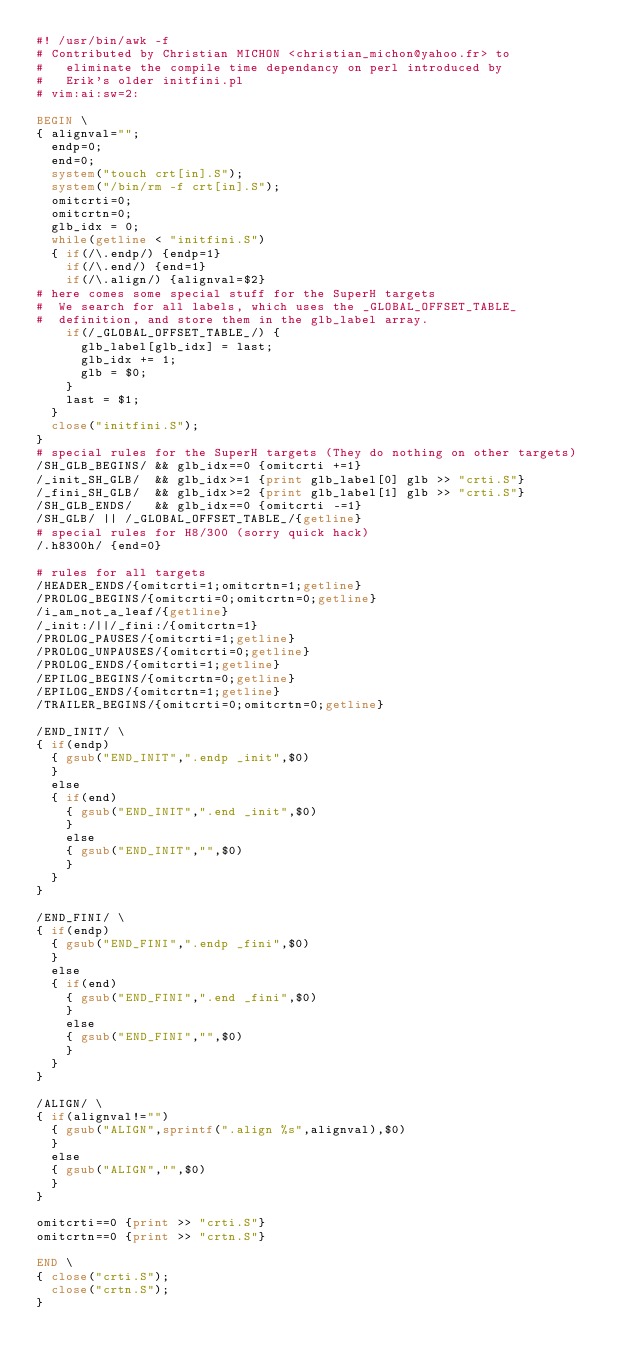Convert code to text. <code><loc_0><loc_0><loc_500><loc_500><_Awk_>#! /usr/bin/awk -f
# Contributed by Christian MICHON <christian_michon@yahoo.fr> to
#   eliminate the compile time dependancy on perl introduced by 
#   Erik's older initfini.pl 
# vim:ai:sw=2:

BEGIN \
{ alignval="";
  endp=0;
  end=0;
  system("touch crt[in].S");
  system("/bin/rm -f crt[in].S");
  omitcrti=0;
  omitcrtn=0;
  glb_idx = 0;
  while(getline < "initfini.S")
  { if(/\.endp/) {endp=1}
    if(/\.end/) {end=1}
    if(/\.align/) {alignval=$2}
# here comes some special stuff for the SuperH targets
#  We search for all labels, which uses the _GLOBAL_OFFSET_TABLE_
#  definition, and store them in the glb_label array.
    if(/_GLOBAL_OFFSET_TABLE_/) {
      glb_label[glb_idx] = last;
      glb_idx += 1;
      glb = $0;
    }
    last = $1;
  }
  close("initfini.S");
}
# special rules for the SuperH targets (They do nothing on other targets)
/SH_GLB_BEGINS/ && glb_idx==0 {omitcrti +=1}
/_init_SH_GLB/  && glb_idx>=1 {print glb_label[0] glb >> "crti.S"}
/_fini_SH_GLB/  && glb_idx>=2 {print glb_label[1] glb >> "crti.S"}
/SH_GLB_ENDS/   && glb_idx==0 {omitcrti -=1}
/SH_GLB/ || /_GLOBAL_OFFSET_TABLE_/{getline}
# special rules for H8/300 (sorry quick hack)
/.h8300h/ {end=0}

# rules for all targets
/HEADER_ENDS/{omitcrti=1;omitcrtn=1;getline}
/PROLOG_BEGINS/{omitcrti=0;omitcrtn=0;getline}
/i_am_not_a_leaf/{getline}
/_init:/||/_fini:/{omitcrtn=1}
/PROLOG_PAUSES/{omitcrti=1;getline}
/PROLOG_UNPAUSES/{omitcrti=0;getline}
/PROLOG_ENDS/{omitcrti=1;getline}
/EPILOG_BEGINS/{omitcrtn=0;getline}
/EPILOG_ENDS/{omitcrtn=1;getline}
/TRAILER_BEGINS/{omitcrti=0;omitcrtn=0;getline}

/END_INIT/ \
{ if(endp)
  { gsub("END_INIT",".endp _init",$0)
  }
  else
  { if(end)
    { gsub("END_INIT",".end _init",$0)
    }
    else
    { gsub("END_INIT","",$0)
    }
  }
}

/END_FINI/ \
{ if(endp)
  { gsub("END_FINI",".endp _fini",$0)
  }
  else
  { if(end)
    { gsub("END_FINI",".end _fini",$0)
    }
    else
    { gsub("END_FINI","",$0)
    }
  }
}

/ALIGN/ \
{ if(alignval!="")
  { gsub("ALIGN",sprintf(".align %s",alignval),$0)
  }
  else
  { gsub("ALIGN","",$0)
  }
}

omitcrti==0 {print >> "crti.S"}
omitcrtn==0 {print >> "crtn.S"}

END \
{ close("crti.S");
  close("crtn.S");
}
</code> 